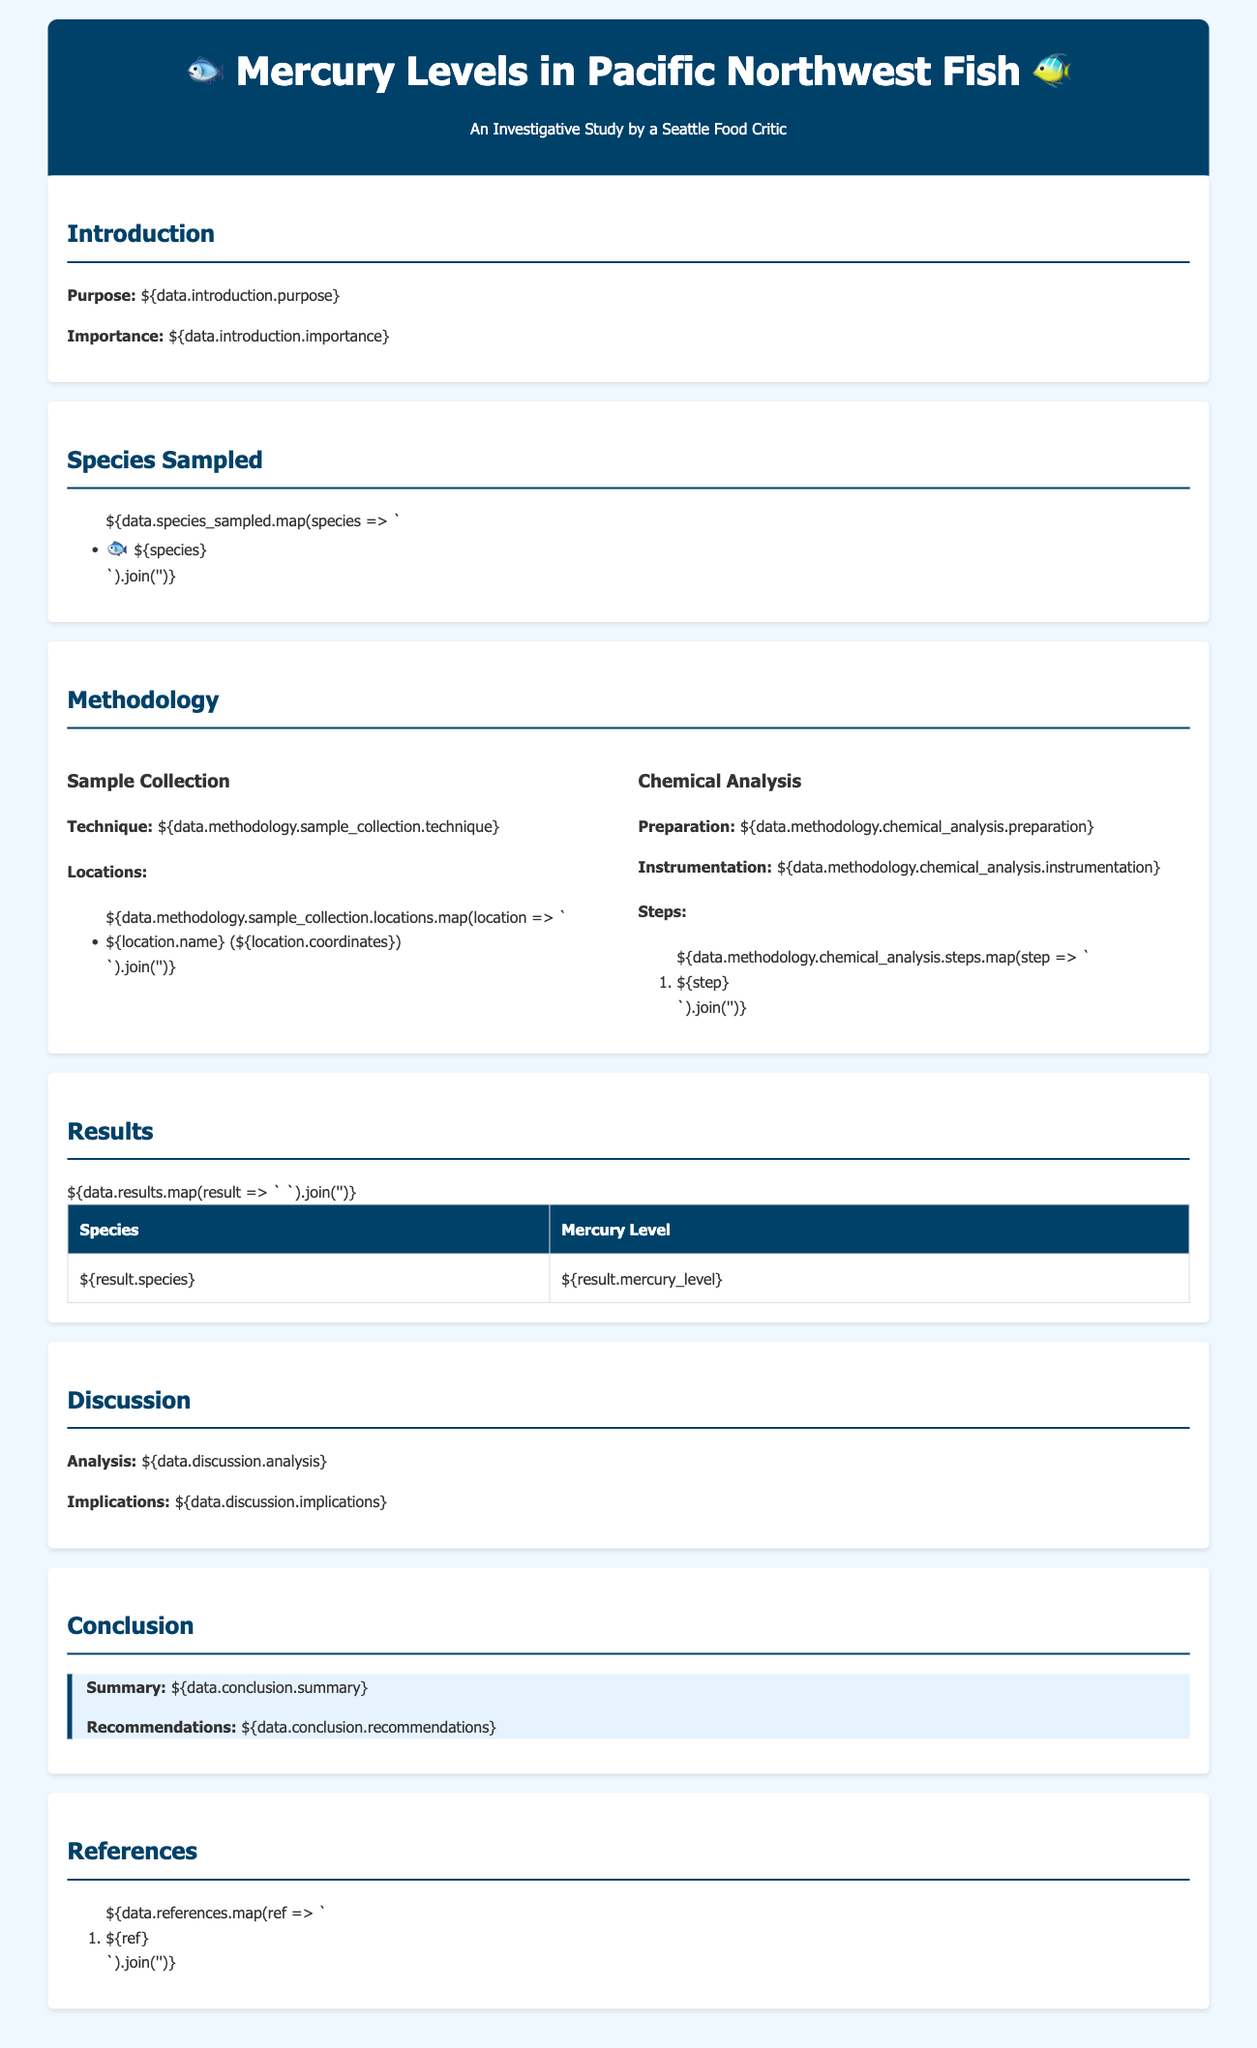what is the purpose of the study? The purpose of the study is explicitly stated in the introduction section of the document.
Answer: To investigate mercury levels in Pacific Northwest fish what species were sampled? The document lists the species sampled in the relevant section.
Answer: Salmon, Halibut, Rockfish, Cod, Clams what sampling technique was used? The methodology section explains the technique used for sample collection.
Answer: Random sampling how many steps were involved in the chemical analysis? The number of steps is specified in the methodology section under chemical analysis.
Answer: Five steps what were the mercury levels for Halibut? The results table details the mercury levels for various fish species, including Halibut.
Answer: 0.45 ppm what is one implication of the analysis? The implications are discussed in the discussion section providing insights into the findings.
Answer: Increased health risks for consumers what is the recommendation given in the conclusion? The conclusion contains recommendations based on the findings of the study.
Answer: Limit consumption of high-mercury fish what is the date of the study? The date is often found in the introduction or conclusion; however, this specific document does not mention it.
Answer: Not specified 